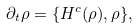<formula> <loc_0><loc_0><loc_500><loc_500>\partial _ { t } \rho = \{ H ^ { c } ( \rho ) , \rho \} ,</formula> 